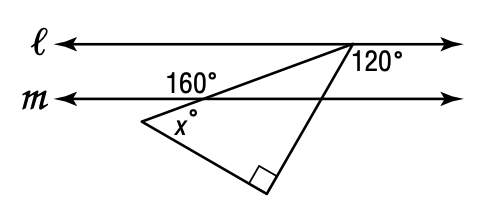Question: Line l is parallel to line m. What is the value of x?
Choices:
A. 30
B. 40
C. 50
D. 60
Answer with the letter. Answer: C 